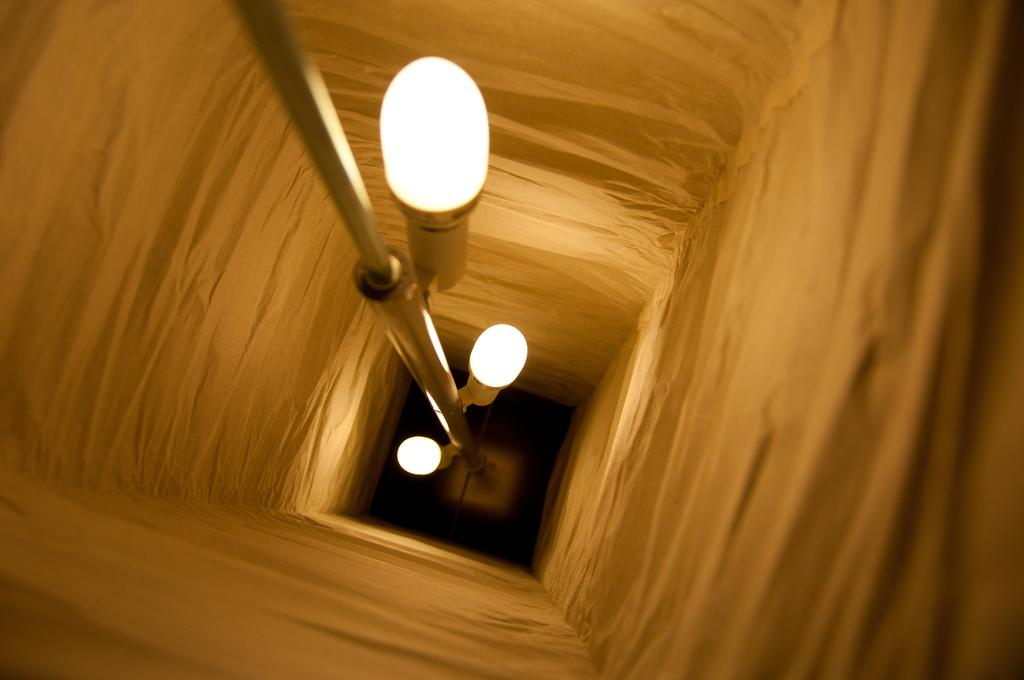What is the main object in the image? There is a pole in the image. What is attached to the pole? There are lights on the pole. What is visible in the background of the image? There is a wall in the image. Can you see any goats grazing near the pole in the image? There are no goats present in the image. What type of harbor can be seen in the background of the image? There is no harbor visible in the image; it only features a pole with lights and a wall in the background. 